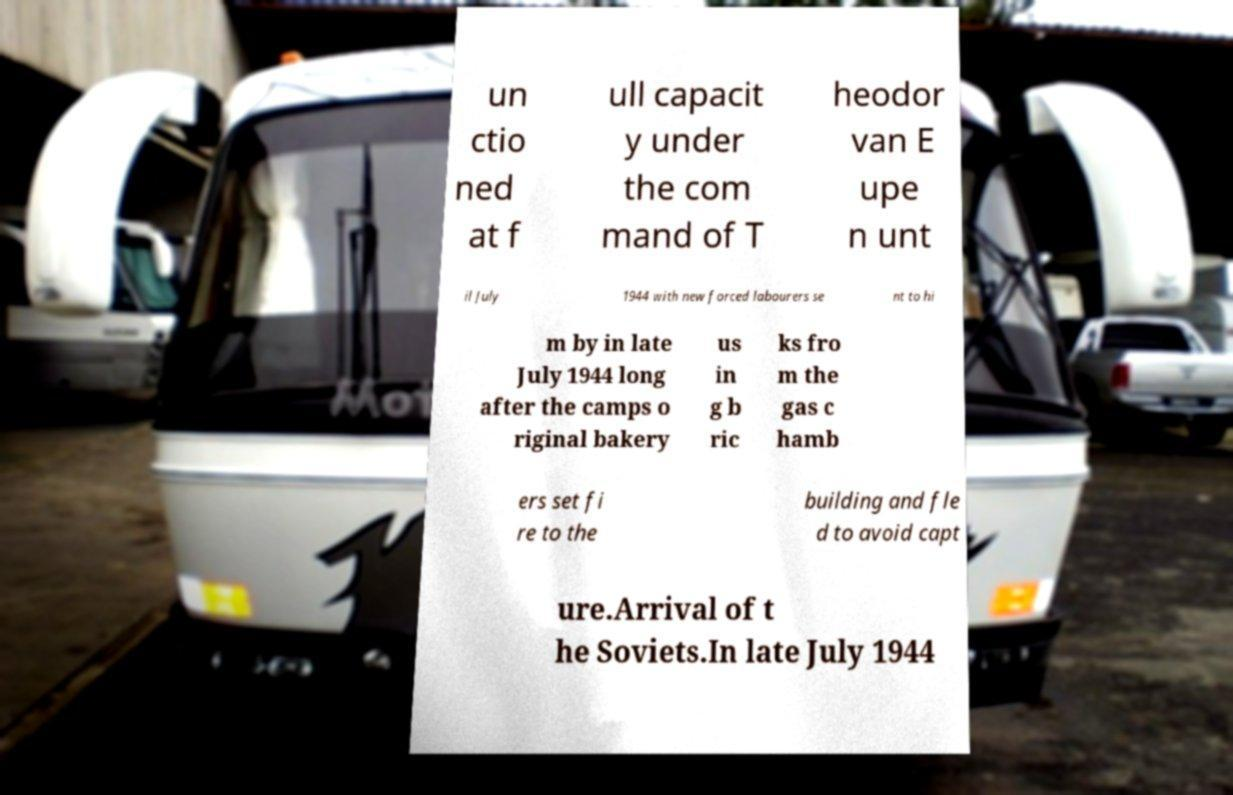What messages or text are displayed in this image? I need them in a readable, typed format. un ctio ned at f ull capacit y under the com mand of T heodor van E upe n unt il July 1944 with new forced labourers se nt to hi m by in late July 1944 long after the camps o riginal bakery us in g b ric ks fro m the gas c hamb ers set fi re to the building and fle d to avoid capt ure.Arrival of t he Soviets.In late July 1944 